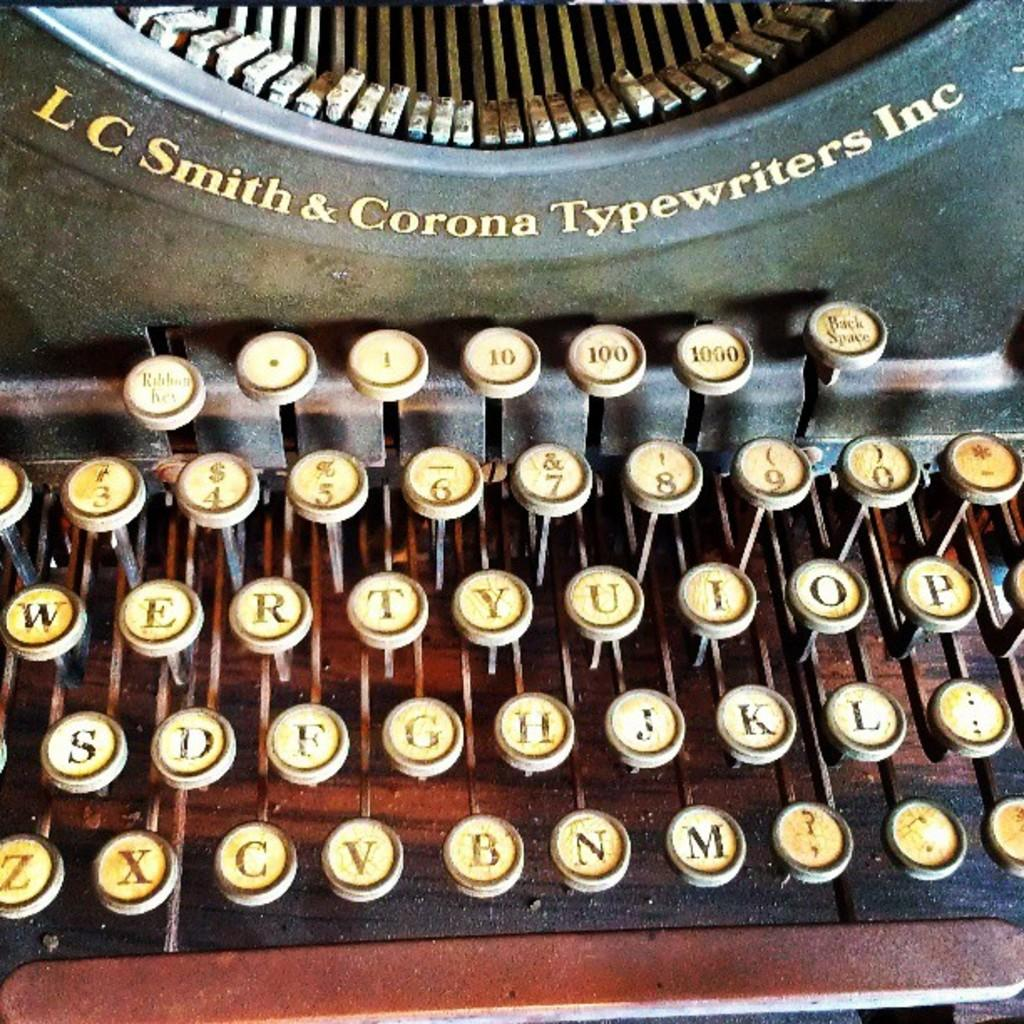<image>
Write a terse but informative summary of the picture. A very old L C Smith & Corona Typewriter has white keys with visible printing stamps. 